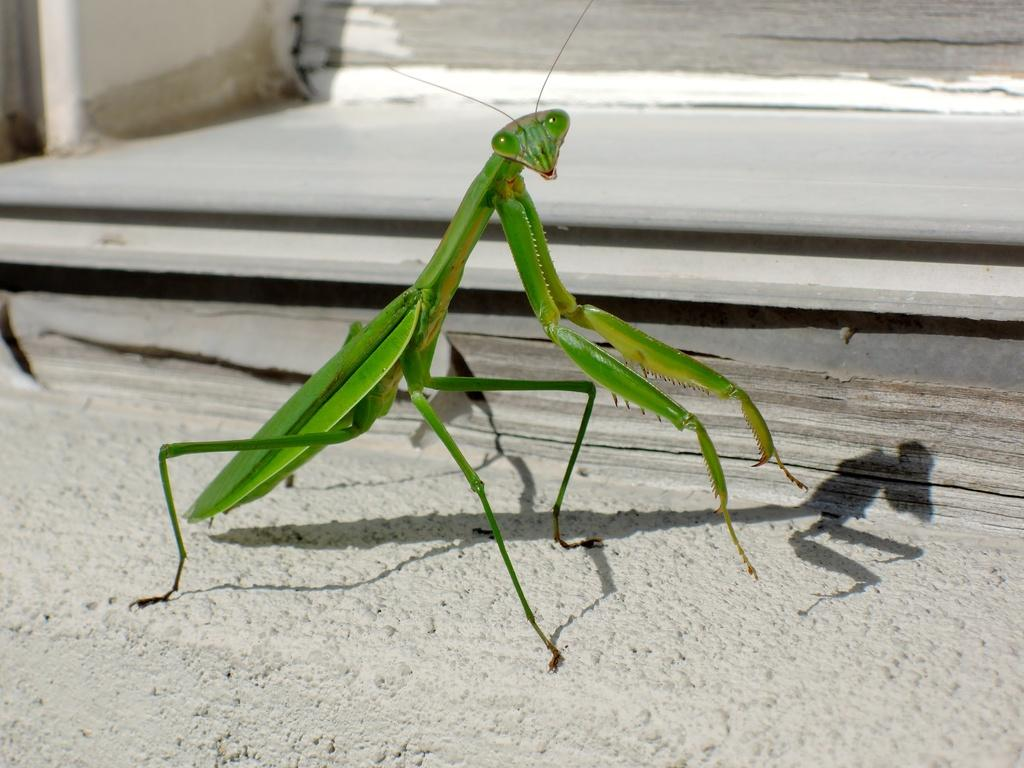What type of insect is present in the image? There is a grasshopper in the image. What type of potato is the grasshopper holding in its hand in the image? There is no potato present in the image, nor is the grasshopper holding anything in its hand. 